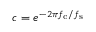Convert formula to latex. <formula><loc_0><loc_0><loc_500><loc_500>c = e ^ { - 2 \pi f _ { c } / f _ { s } }</formula> 